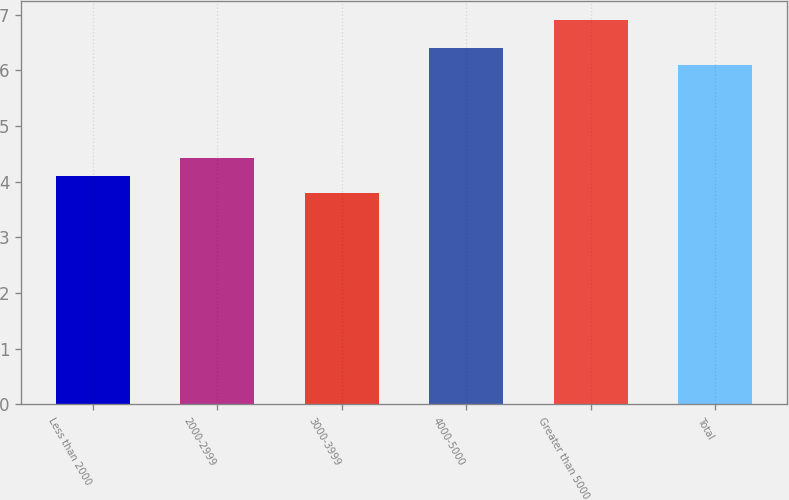Convert chart to OTSL. <chart><loc_0><loc_0><loc_500><loc_500><bar_chart><fcel>Less than 2000<fcel>2000-2999<fcel>3000-3999<fcel>4000-5000<fcel>Greater than 5000<fcel>Total<nl><fcel>4.11<fcel>4.42<fcel>3.8<fcel>6.41<fcel>6.9<fcel>6.1<nl></chart> 